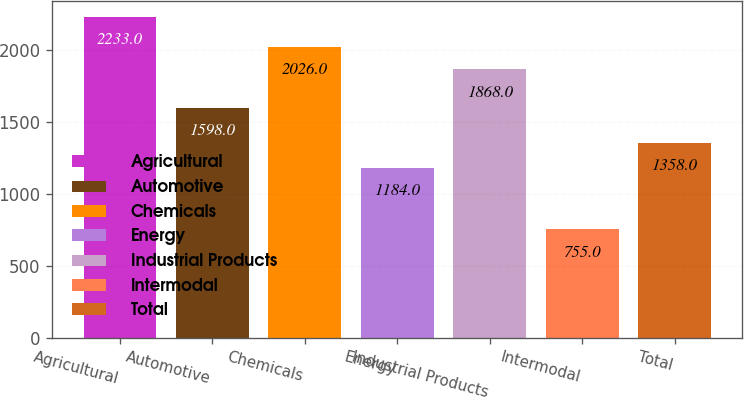Convert chart to OTSL. <chart><loc_0><loc_0><loc_500><loc_500><bar_chart><fcel>Agricultural<fcel>Automotive<fcel>Chemicals<fcel>Energy<fcel>Industrial Products<fcel>Intermodal<fcel>Total<nl><fcel>2233<fcel>1598<fcel>2026<fcel>1184<fcel>1868<fcel>755<fcel>1358<nl></chart> 